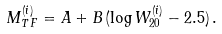Convert formula to latex. <formula><loc_0><loc_0><loc_500><loc_500>M _ { T \, F } ^ { ( i ) } = A + B \, ( \log W _ { 2 0 } ^ { ( i ) } - 2 . 5 ) \, .</formula> 